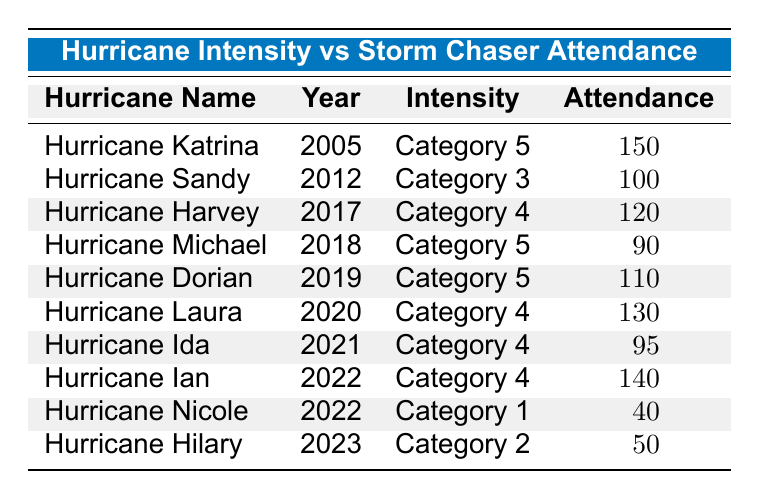What is the storm chaser attendance for Hurricane Dorian? The table lists Hurricane Dorian under the "Hurricane Name" column, and its corresponding attendance value in the "Attendance" column is 110.
Answer: 110 What hurricane had the highest storm chaser attendance? By examining the "Attendance" column, Hurricane Katrina has the highest attendance value of 150 compared to the other hurricanes listed in the table.
Answer: Hurricane Katrina Is it true that Hurricane Michael had more storm chaser attendance than Hurricane Ida? Comparing the attendance values in the table, Hurricane Michael's attendance is 90 and Hurricane Ida's is 95. Therefore, Hurricane Michael did not have more attendance than Hurricane Ida.
Answer: No What is the total storm chaser attendance for all Category 5 hurricanes combined? The table shows two Category 5 hurricanes: Hurricane Katrina (150) and Hurricane Dorian (110) along with Hurricane Michael (90). Adding these gives a total of 150 + 90 + 110 = 350.
Answer: 350 Which hurricane had the lowest storm chaser attendance? Looking through the "Attendance" column, Hurricane Nicole shows the lowest attendance with a value of 40.
Answer: Hurricane Nicole What is the average storm chaser attendance for Category 4 hurricanes? The Category 4 hurricanes in the table are Hurricane Harvey (120), Hurricane Laura (130), Hurricane Ida (95), and Hurricane Ian (140). Summing these, we get 120 + 130 + 95 + 140 = 485. As there are four data points, dividing gives the average attendance of 485 / 4 = 121.25.
Answer: 121.25 Did more storm chasers attend Hurricane Sandy or Hurricane Hilary? Checking the attendance numbers, Hurricane Sandy had 100 and Hurricane Hilary had 50. Since 100 > 50, more storm chasers attended Hurricane Sandy.
Answer: Yes How many storm chasers attended hurricanes that are Category 2 and Category 3? The table indicates Hurricane Sandy (Category 3) had 100 storm chasers, and Hurricane Hilary (Category 2) had 50. Therefore, the total would be 100 + 50 = 150.
Answer: 150 